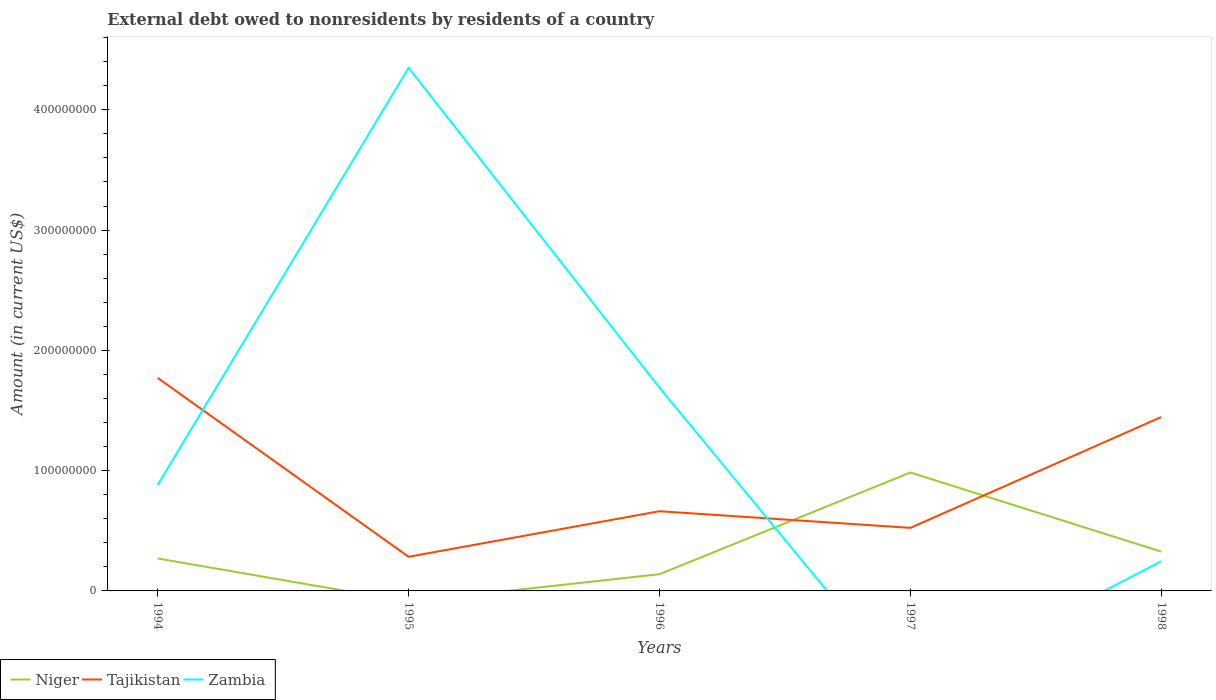Does the line corresponding to Tajikistan intersect with the line corresponding to Niger?
Give a very brief answer. Yes. What is the total external debt owed by residents in Tajikistan in the graph?
Your response must be concise. 1.38e+07. What is the difference between the highest and the second highest external debt owed by residents in Zambia?
Provide a short and direct response. 4.35e+08. Is the external debt owed by residents in Zambia strictly greater than the external debt owed by residents in Niger over the years?
Make the answer very short. No. What is the difference between two consecutive major ticks on the Y-axis?
Provide a succinct answer. 1.00e+08. Does the graph contain any zero values?
Keep it short and to the point. Yes. How many legend labels are there?
Offer a very short reply. 3. How are the legend labels stacked?
Give a very brief answer. Horizontal. What is the title of the graph?
Your answer should be compact. External debt owed to nonresidents by residents of a country. Does "Bosnia and Herzegovina" appear as one of the legend labels in the graph?
Ensure brevity in your answer.  No. What is the label or title of the X-axis?
Offer a terse response. Years. What is the Amount (in current US$) in Niger in 1994?
Keep it short and to the point. 2.70e+07. What is the Amount (in current US$) in Tajikistan in 1994?
Offer a terse response. 1.77e+08. What is the Amount (in current US$) of Zambia in 1994?
Your answer should be very brief. 8.81e+07. What is the Amount (in current US$) in Niger in 1995?
Make the answer very short. 0. What is the Amount (in current US$) of Tajikistan in 1995?
Make the answer very short. 2.84e+07. What is the Amount (in current US$) in Zambia in 1995?
Ensure brevity in your answer.  4.35e+08. What is the Amount (in current US$) of Niger in 1996?
Provide a succinct answer. 1.39e+07. What is the Amount (in current US$) in Tajikistan in 1996?
Your answer should be compact. 6.63e+07. What is the Amount (in current US$) in Zambia in 1996?
Offer a very short reply. 1.69e+08. What is the Amount (in current US$) in Niger in 1997?
Offer a terse response. 9.85e+07. What is the Amount (in current US$) of Tajikistan in 1997?
Offer a very short reply. 5.24e+07. What is the Amount (in current US$) in Zambia in 1997?
Your response must be concise. 0. What is the Amount (in current US$) of Niger in 1998?
Your answer should be compact. 3.27e+07. What is the Amount (in current US$) in Tajikistan in 1998?
Ensure brevity in your answer.  1.45e+08. What is the Amount (in current US$) of Zambia in 1998?
Provide a succinct answer. 2.47e+07. Across all years, what is the maximum Amount (in current US$) in Niger?
Your response must be concise. 9.85e+07. Across all years, what is the maximum Amount (in current US$) of Tajikistan?
Offer a very short reply. 1.77e+08. Across all years, what is the maximum Amount (in current US$) of Zambia?
Make the answer very short. 4.35e+08. Across all years, what is the minimum Amount (in current US$) of Niger?
Your answer should be very brief. 0. Across all years, what is the minimum Amount (in current US$) of Tajikistan?
Your answer should be very brief. 2.84e+07. What is the total Amount (in current US$) in Niger in the graph?
Offer a very short reply. 1.72e+08. What is the total Amount (in current US$) of Tajikistan in the graph?
Provide a succinct answer. 4.69e+08. What is the total Amount (in current US$) of Zambia in the graph?
Provide a short and direct response. 7.17e+08. What is the difference between the Amount (in current US$) in Tajikistan in 1994 and that in 1995?
Your response must be concise. 1.49e+08. What is the difference between the Amount (in current US$) of Zambia in 1994 and that in 1995?
Your answer should be compact. -3.47e+08. What is the difference between the Amount (in current US$) of Niger in 1994 and that in 1996?
Your response must be concise. 1.31e+07. What is the difference between the Amount (in current US$) of Tajikistan in 1994 and that in 1996?
Your answer should be compact. 1.11e+08. What is the difference between the Amount (in current US$) of Zambia in 1994 and that in 1996?
Offer a very short reply. -8.09e+07. What is the difference between the Amount (in current US$) in Niger in 1994 and that in 1997?
Offer a very short reply. -7.15e+07. What is the difference between the Amount (in current US$) of Tajikistan in 1994 and that in 1997?
Your response must be concise. 1.25e+08. What is the difference between the Amount (in current US$) in Niger in 1994 and that in 1998?
Provide a succinct answer. -5.69e+06. What is the difference between the Amount (in current US$) of Tajikistan in 1994 and that in 1998?
Provide a succinct answer. 3.25e+07. What is the difference between the Amount (in current US$) of Zambia in 1994 and that in 1998?
Ensure brevity in your answer.  6.34e+07. What is the difference between the Amount (in current US$) in Tajikistan in 1995 and that in 1996?
Offer a terse response. -3.79e+07. What is the difference between the Amount (in current US$) in Zambia in 1995 and that in 1996?
Keep it short and to the point. 2.66e+08. What is the difference between the Amount (in current US$) of Tajikistan in 1995 and that in 1997?
Your answer should be very brief. -2.41e+07. What is the difference between the Amount (in current US$) of Tajikistan in 1995 and that in 1998?
Provide a succinct answer. -1.16e+08. What is the difference between the Amount (in current US$) of Zambia in 1995 and that in 1998?
Your response must be concise. 4.10e+08. What is the difference between the Amount (in current US$) of Niger in 1996 and that in 1997?
Provide a succinct answer. -8.46e+07. What is the difference between the Amount (in current US$) of Tajikistan in 1996 and that in 1997?
Your response must be concise. 1.38e+07. What is the difference between the Amount (in current US$) of Niger in 1996 and that in 1998?
Keep it short and to the point. -1.88e+07. What is the difference between the Amount (in current US$) of Tajikistan in 1996 and that in 1998?
Offer a terse response. -7.83e+07. What is the difference between the Amount (in current US$) in Zambia in 1996 and that in 1998?
Your response must be concise. 1.44e+08. What is the difference between the Amount (in current US$) in Niger in 1997 and that in 1998?
Your answer should be compact. 6.58e+07. What is the difference between the Amount (in current US$) in Tajikistan in 1997 and that in 1998?
Ensure brevity in your answer.  -9.22e+07. What is the difference between the Amount (in current US$) in Niger in 1994 and the Amount (in current US$) in Tajikistan in 1995?
Your answer should be compact. -1.38e+06. What is the difference between the Amount (in current US$) in Niger in 1994 and the Amount (in current US$) in Zambia in 1995?
Ensure brevity in your answer.  -4.08e+08. What is the difference between the Amount (in current US$) of Tajikistan in 1994 and the Amount (in current US$) of Zambia in 1995?
Make the answer very short. -2.58e+08. What is the difference between the Amount (in current US$) of Niger in 1994 and the Amount (in current US$) of Tajikistan in 1996?
Your answer should be compact. -3.93e+07. What is the difference between the Amount (in current US$) of Niger in 1994 and the Amount (in current US$) of Zambia in 1996?
Provide a short and direct response. -1.42e+08. What is the difference between the Amount (in current US$) of Tajikistan in 1994 and the Amount (in current US$) of Zambia in 1996?
Ensure brevity in your answer.  8.10e+06. What is the difference between the Amount (in current US$) in Niger in 1994 and the Amount (in current US$) in Tajikistan in 1997?
Make the answer very short. -2.54e+07. What is the difference between the Amount (in current US$) in Niger in 1994 and the Amount (in current US$) in Tajikistan in 1998?
Your answer should be compact. -1.18e+08. What is the difference between the Amount (in current US$) of Niger in 1994 and the Amount (in current US$) of Zambia in 1998?
Provide a short and direct response. 2.31e+06. What is the difference between the Amount (in current US$) of Tajikistan in 1994 and the Amount (in current US$) of Zambia in 1998?
Your answer should be very brief. 1.52e+08. What is the difference between the Amount (in current US$) of Tajikistan in 1995 and the Amount (in current US$) of Zambia in 1996?
Provide a succinct answer. -1.41e+08. What is the difference between the Amount (in current US$) of Tajikistan in 1995 and the Amount (in current US$) of Zambia in 1998?
Provide a succinct answer. 3.68e+06. What is the difference between the Amount (in current US$) of Niger in 1996 and the Amount (in current US$) of Tajikistan in 1997?
Your response must be concise. -3.85e+07. What is the difference between the Amount (in current US$) in Niger in 1996 and the Amount (in current US$) in Tajikistan in 1998?
Make the answer very short. -1.31e+08. What is the difference between the Amount (in current US$) in Niger in 1996 and the Amount (in current US$) in Zambia in 1998?
Offer a very short reply. -1.08e+07. What is the difference between the Amount (in current US$) in Tajikistan in 1996 and the Amount (in current US$) in Zambia in 1998?
Provide a succinct answer. 4.16e+07. What is the difference between the Amount (in current US$) of Niger in 1997 and the Amount (in current US$) of Tajikistan in 1998?
Ensure brevity in your answer.  -4.61e+07. What is the difference between the Amount (in current US$) in Niger in 1997 and the Amount (in current US$) in Zambia in 1998?
Give a very brief answer. 7.38e+07. What is the difference between the Amount (in current US$) of Tajikistan in 1997 and the Amount (in current US$) of Zambia in 1998?
Provide a succinct answer. 2.77e+07. What is the average Amount (in current US$) in Niger per year?
Make the answer very short. 3.44e+07. What is the average Amount (in current US$) of Tajikistan per year?
Your answer should be compact. 9.38e+07. What is the average Amount (in current US$) in Zambia per year?
Make the answer very short. 1.43e+08. In the year 1994, what is the difference between the Amount (in current US$) of Niger and Amount (in current US$) of Tajikistan?
Offer a terse response. -1.50e+08. In the year 1994, what is the difference between the Amount (in current US$) of Niger and Amount (in current US$) of Zambia?
Make the answer very short. -6.11e+07. In the year 1994, what is the difference between the Amount (in current US$) in Tajikistan and Amount (in current US$) in Zambia?
Keep it short and to the point. 8.90e+07. In the year 1995, what is the difference between the Amount (in current US$) of Tajikistan and Amount (in current US$) of Zambia?
Your answer should be compact. -4.07e+08. In the year 1996, what is the difference between the Amount (in current US$) of Niger and Amount (in current US$) of Tajikistan?
Your answer should be very brief. -5.24e+07. In the year 1996, what is the difference between the Amount (in current US$) of Niger and Amount (in current US$) of Zambia?
Offer a very short reply. -1.55e+08. In the year 1996, what is the difference between the Amount (in current US$) in Tajikistan and Amount (in current US$) in Zambia?
Your answer should be compact. -1.03e+08. In the year 1997, what is the difference between the Amount (in current US$) in Niger and Amount (in current US$) in Tajikistan?
Give a very brief answer. 4.60e+07. In the year 1998, what is the difference between the Amount (in current US$) in Niger and Amount (in current US$) in Tajikistan?
Offer a very short reply. -1.12e+08. In the year 1998, what is the difference between the Amount (in current US$) of Niger and Amount (in current US$) of Zambia?
Your response must be concise. 8.00e+06. In the year 1998, what is the difference between the Amount (in current US$) of Tajikistan and Amount (in current US$) of Zambia?
Provide a short and direct response. 1.20e+08. What is the ratio of the Amount (in current US$) in Tajikistan in 1994 to that in 1995?
Your answer should be compact. 6.24. What is the ratio of the Amount (in current US$) of Zambia in 1994 to that in 1995?
Your answer should be very brief. 0.2. What is the ratio of the Amount (in current US$) of Niger in 1994 to that in 1996?
Your answer should be very brief. 1.94. What is the ratio of the Amount (in current US$) of Tajikistan in 1994 to that in 1996?
Make the answer very short. 2.67. What is the ratio of the Amount (in current US$) in Zambia in 1994 to that in 1996?
Make the answer very short. 0.52. What is the ratio of the Amount (in current US$) of Niger in 1994 to that in 1997?
Ensure brevity in your answer.  0.27. What is the ratio of the Amount (in current US$) of Tajikistan in 1994 to that in 1997?
Provide a short and direct response. 3.38. What is the ratio of the Amount (in current US$) of Niger in 1994 to that in 1998?
Ensure brevity in your answer.  0.83. What is the ratio of the Amount (in current US$) in Tajikistan in 1994 to that in 1998?
Your answer should be compact. 1.22. What is the ratio of the Amount (in current US$) in Zambia in 1994 to that in 1998?
Offer a terse response. 3.57. What is the ratio of the Amount (in current US$) in Tajikistan in 1995 to that in 1996?
Provide a short and direct response. 0.43. What is the ratio of the Amount (in current US$) in Zambia in 1995 to that in 1996?
Your answer should be very brief. 2.57. What is the ratio of the Amount (in current US$) in Tajikistan in 1995 to that in 1997?
Give a very brief answer. 0.54. What is the ratio of the Amount (in current US$) of Tajikistan in 1995 to that in 1998?
Offer a very short reply. 0.2. What is the ratio of the Amount (in current US$) of Zambia in 1995 to that in 1998?
Ensure brevity in your answer.  17.62. What is the ratio of the Amount (in current US$) in Niger in 1996 to that in 1997?
Offer a terse response. 0.14. What is the ratio of the Amount (in current US$) of Tajikistan in 1996 to that in 1997?
Offer a terse response. 1.26. What is the ratio of the Amount (in current US$) of Niger in 1996 to that in 1998?
Your answer should be compact. 0.42. What is the ratio of the Amount (in current US$) in Tajikistan in 1996 to that in 1998?
Provide a succinct answer. 0.46. What is the ratio of the Amount (in current US$) in Zambia in 1996 to that in 1998?
Make the answer very short. 6.84. What is the ratio of the Amount (in current US$) in Niger in 1997 to that in 1998?
Keep it short and to the point. 3.01. What is the ratio of the Amount (in current US$) of Tajikistan in 1997 to that in 1998?
Provide a succinct answer. 0.36. What is the difference between the highest and the second highest Amount (in current US$) of Niger?
Your answer should be very brief. 6.58e+07. What is the difference between the highest and the second highest Amount (in current US$) in Tajikistan?
Offer a very short reply. 3.25e+07. What is the difference between the highest and the second highest Amount (in current US$) in Zambia?
Ensure brevity in your answer.  2.66e+08. What is the difference between the highest and the lowest Amount (in current US$) in Niger?
Keep it short and to the point. 9.85e+07. What is the difference between the highest and the lowest Amount (in current US$) of Tajikistan?
Provide a succinct answer. 1.49e+08. What is the difference between the highest and the lowest Amount (in current US$) in Zambia?
Offer a very short reply. 4.35e+08. 